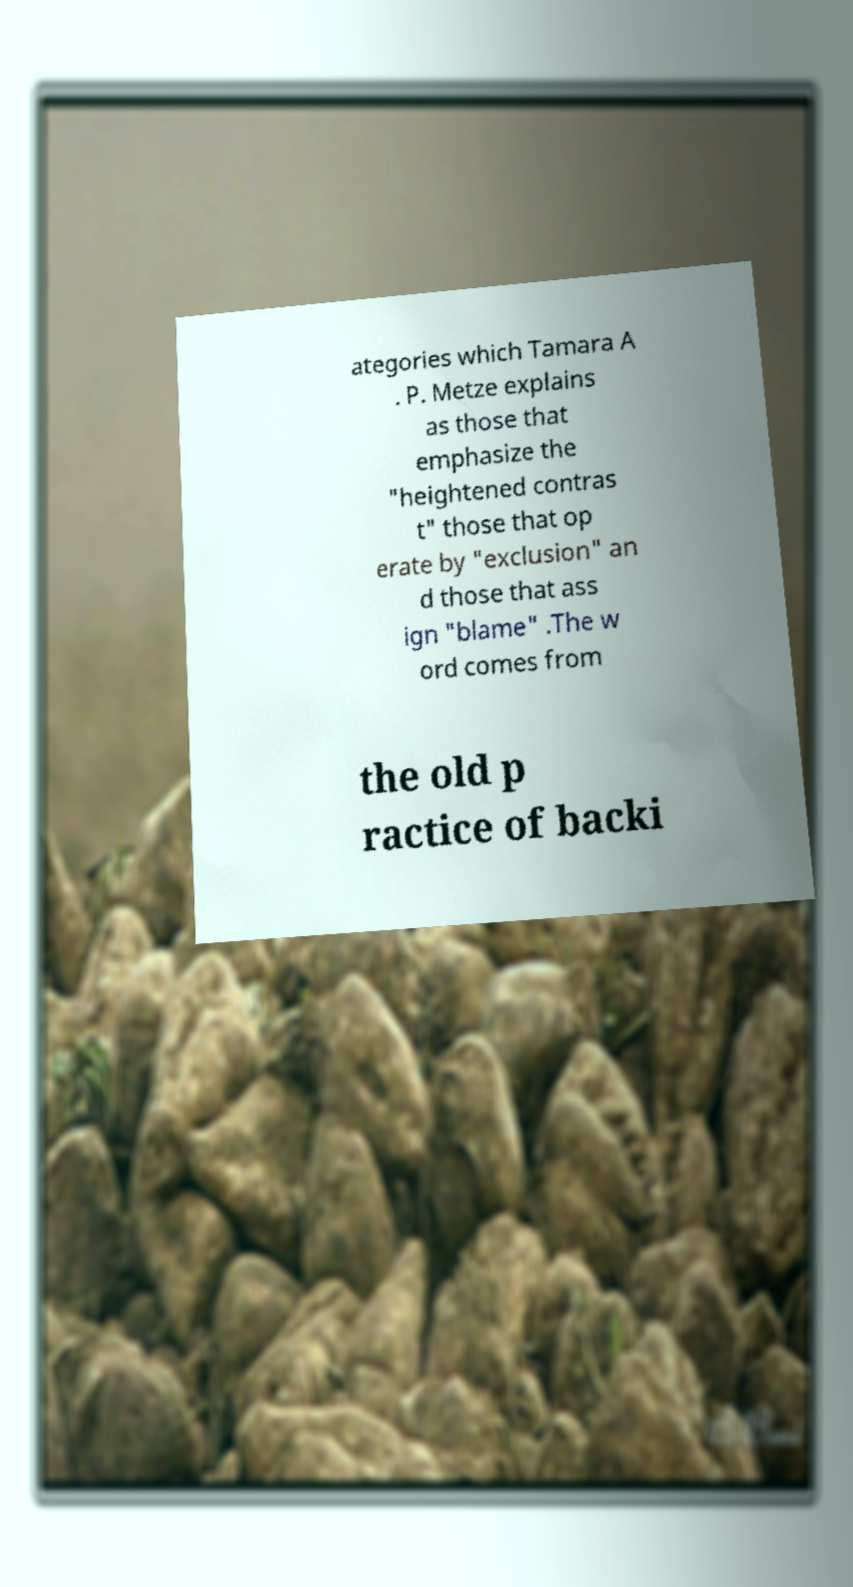Could you extract and type out the text from this image? ategories which Tamara A . P. Metze explains as those that emphasize the "heightened contras t" those that op erate by "exclusion" an d those that ass ign "blame" .The w ord comes from the old p ractice of backi 